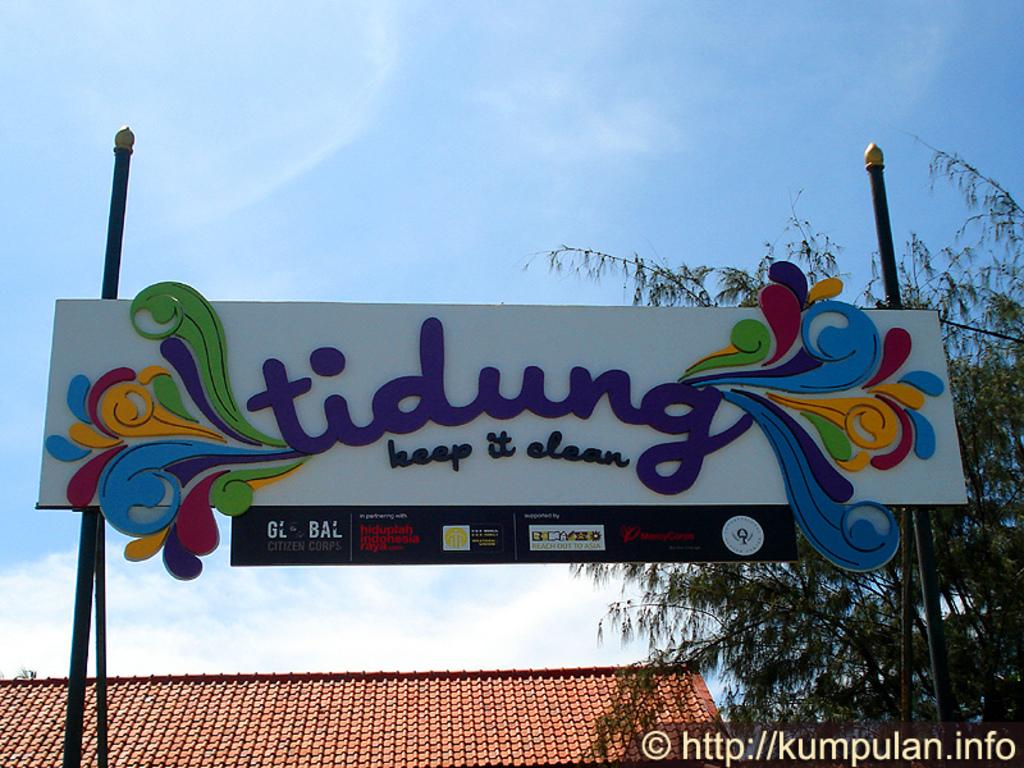<image>
Relay a brief, clear account of the picture shown. A sign encouraging people to keep tidung clean has colorful waves by each side edge. 